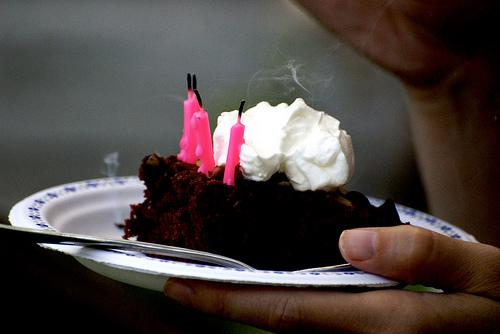Describe the interaction between the person and the plate. A person is holding the plate with their hand, and their index finger is on the edge of the plate. Mention the objects related to the birthday celebration in the image. The objects related to the birthday celebration are bright pink candles, whipped cream on a slice of cake, and smoke from the blown out candles. In what container is the cake slice placed? The cake slice is on a paper plate under a piece of cake. Count the number of significant objects in the image. There are 15 significant objects in the image, including the cake slice, plate, whipped cream, candles, smoke, fork, and various parts of a person's hand. Analyze the overall sentiment and mood of the image. The overall sentiment of the image is joyful and celebratory due to the presence of birthday candles and cake. What is the appearance of the whipped cream on the cake? The whipped cream is white and fluffy. Describe the primary flavor of the cake and how it is served. The primary flavor of the cake is chocolate, and it is served on a blue and white plate. How many candles are there, and describe their condition. There are several candles, and they are pink and have melted wax on them. Identify the primary object and its color in the image. The primary object is a slice of chocolate cake on a white and blue plate. What type of utensil is present in the image, and what is it made of? A silver fork is present in the image. 